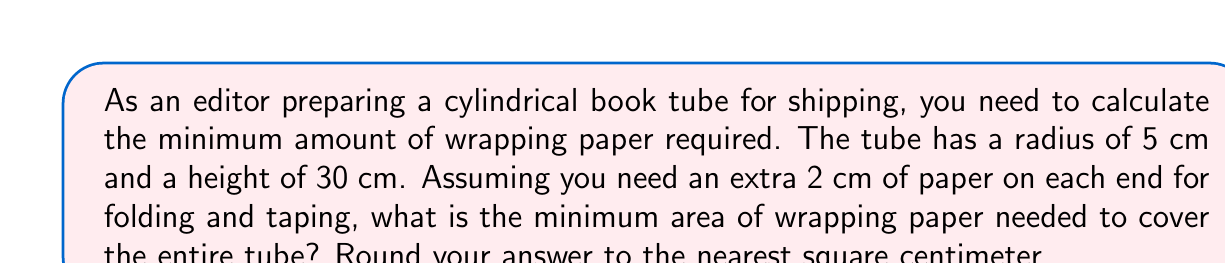Can you answer this question? To solve this problem, we need to consider the surface area of the cylinder plus the additional paper needed for folding and taping. Let's break it down step-by-step:

1. The surface area of a cylinder consists of two circular ends and the lateral surface (rectangle).

2. For the circular ends:
   - Area of one circular end: $A_c = \pi r^2$
   - $A_c = \pi (5\text{ cm})^2 = 25\pi\text{ cm}^2$
   - We need two circular ends, so total area: $2(25\pi)\text{ cm}^2 = 50\pi\text{ cm}^2$

3. For the lateral surface (rectangle):
   - We need to add 2 cm to each end of the height for folding and taping
   - New height: $30\text{ cm} + 2\text{ cm} + 2\text{ cm} = 34\text{ cm}$
   - Circumference of the circular base: $2\pi r = 2\pi(5\text{ cm}) = 10\pi\text{ cm}$
   - Area of rectangle: $A_r = 34\text{ cm} \times 10\pi\text{ cm} = 340\pi\text{ cm}^2$

4. Total surface area:
   $A_{\text{total}} = A_{\text{circular ends}} + A_{\text{rectangle}}$
   $A_{\text{total}} = 50\pi\text{ cm}^2 + 340\pi\text{ cm}^2 = 390\pi\text{ cm}^2$

5. Converting to a numerical value and rounding:
   $A_{\text{total}} = 390\pi\text{ cm}^2 \approx 1225.22\text{ cm}^2$

Rounding to the nearest square centimeter gives us 1225 cm².
Answer: 1225 cm² 